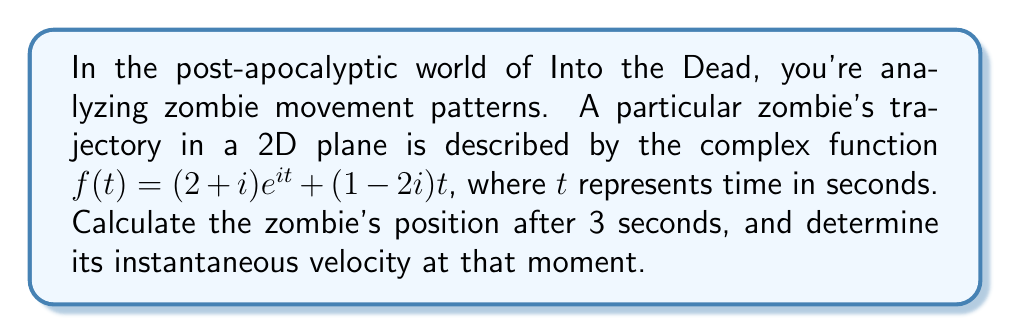Could you help me with this problem? Let's approach this problem step by step:

1) The zombie's position at any time $t$ is given by $f(t) = (2+i)e^{it} + (1-2i)t$

2) To find the position at $t=3$ seconds, we simply substitute $t=3$ into the function:

   $f(3) = (2+i)e^{3i} + (1-2i)(3)$

3) Let's evaluate each part separately:
   
   a) $e^{3i} = \cos(3) + i\sin(3)$
   
   b) $(2+i)e^{3i} = (2+i)(\cos(3) + i\sin(3)) = (2\cos(3) - \sin(3)) + i(2\sin(3) + \cos(3))$
   
   c) $(1-2i)(3) = 3 - 6i$

4) Now, we can add these parts:

   $f(3) = (2\cos(3) - \sin(3) + 3) + i(2\sin(3) + \cos(3) - 6)$

5) To find the instantaneous velocity at $t=3$, we need to differentiate $f(t)$ and then evaluate at $t=3$:

   $f'(t) = i(2+i)e^{it} + (1-2i)$

6) Evaluating at $t=3$:

   $f'(3) = i(2+i)e^{3i} + (1-2i)$
   
   $= i(2+i)(\cos(3) + i\sin(3)) + (1-2i)$
   
   $= (-2\sin(3) - \cos(3) + 1) + i(2\cos(3) - \sin(3) - 2)$

This complex number represents the instantaneous velocity at $t=3$ seconds.
Answer: Position at $t=3$ seconds: $(2\cos(3) - \sin(3) + 3) + i(2\sin(3) + \cos(3) - 6)$

Instantaneous velocity at $t=3$ seconds: $(-2\sin(3) - \cos(3) + 1) + i(2\cos(3) - \sin(3) - 2)$ 